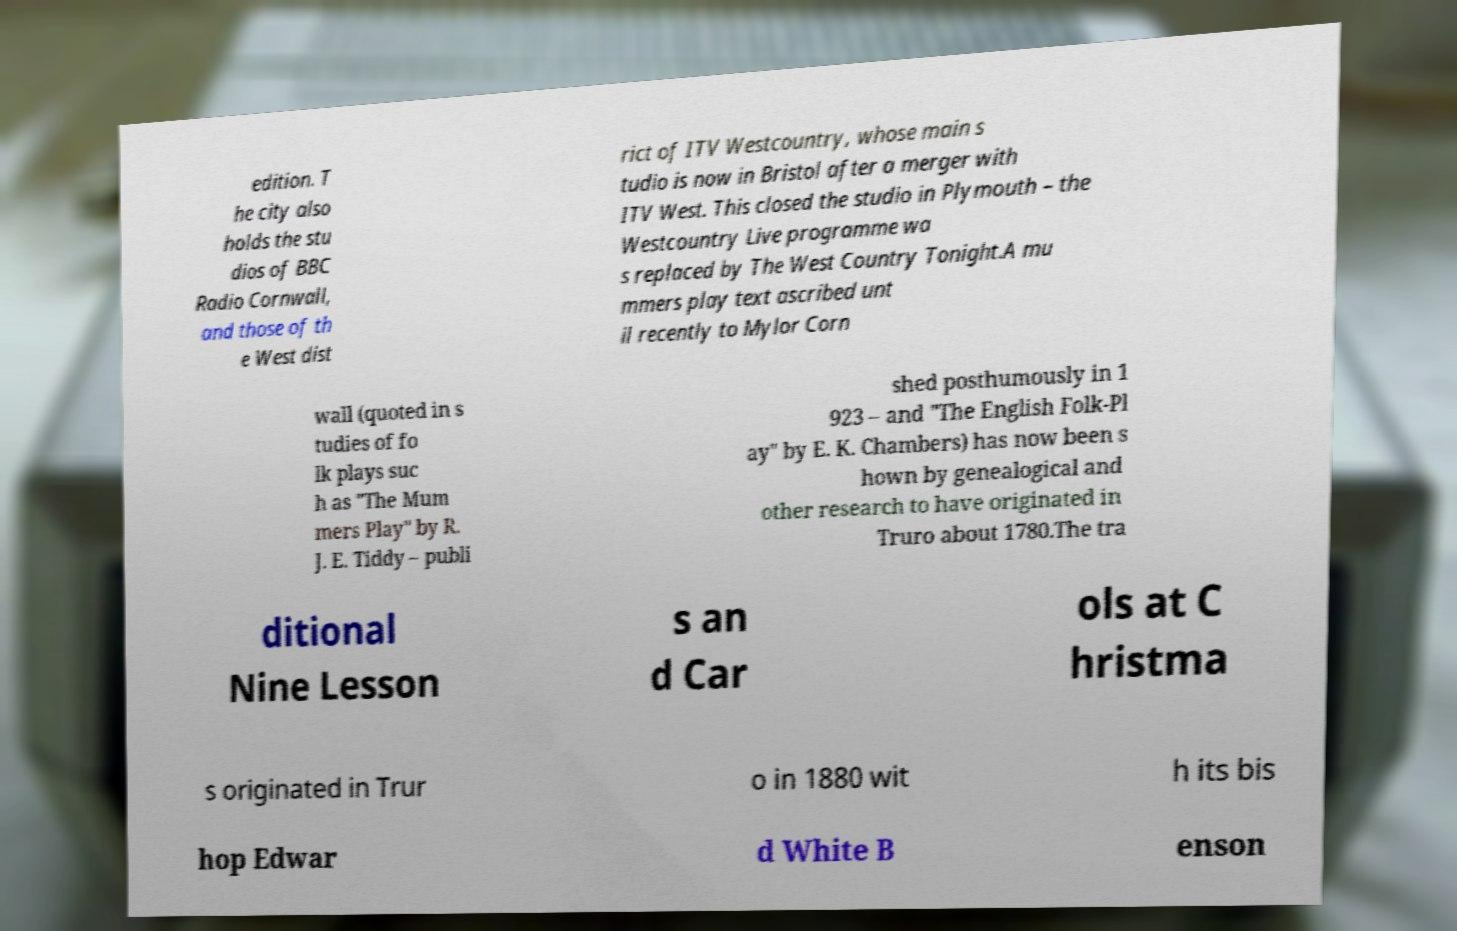What messages or text are displayed in this image? I need them in a readable, typed format. edition. T he city also holds the stu dios of BBC Radio Cornwall, and those of th e West dist rict of ITV Westcountry, whose main s tudio is now in Bristol after a merger with ITV West. This closed the studio in Plymouth – the Westcountry Live programme wa s replaced by The West Country Tonight.A mu mmers play text ascribed unt il recently to Mylor Corn wall (quoted in s tudies of fo lk plays suc h as "The Mum mers Play" by R. J. E. Tiddy – publi shed posthumously in 1 923 – and "The English Folk-Pl ay" by E. K. Chambers) has now been s hown by genealogical and other research to have originated in Truro about 1780.The tra ditional Nine Lesson s an d Car ols at C hristma s originated in Trur o in 1880 wit h its bis hop Edwar d White B enson 